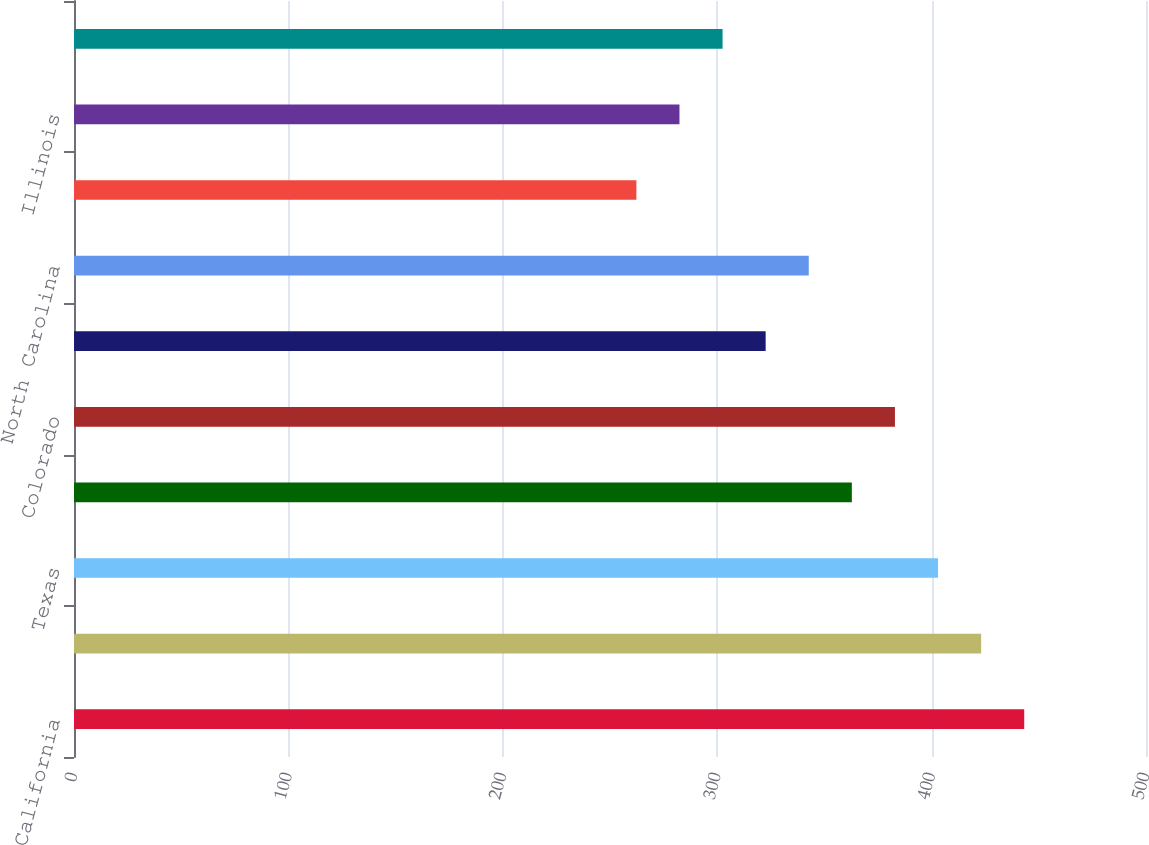Convert chart. <chart><loc_0><loc_0><loc_500><loc_500><bar_chart><fcel>California<fcel>Florida<fcel>Texas<fcel>Georgia<fcel>Colorado<fcel>Ohio<fcel>North Carolina<fcel>Virginia<fcel>Illinois<fcel>Oregon<nl><fcel>443.2<fcel>423.1<fcel>403<fcel>362.8<fcel>382.9<fcel>322.6<fcel>342.7<fcel>262.3<fcel>282.4<fcel>302.5<nl></chart> 